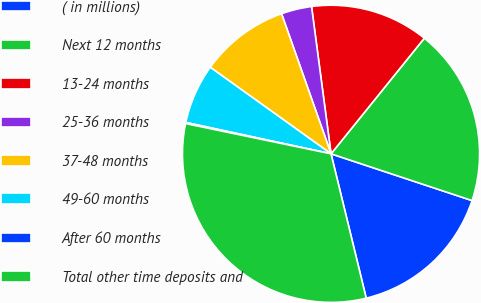Convert chart to OTSL. <chart><loc_0><loc_0><loc_500><loc_500><pie_chart><fcel>( in millions)<fcel>Next 12 months<fcel>13-24 months<fcel>25-36 months<fcel>37-48 months<fcel>49-60 months<fcel>After 60 months<fcel>Total other time deposits and<nl><fcel>16.1%<fcel>19.29%<fcel>12.9%<fcel>3.31%<fcel>9.7%<fcel>6.51%<fcel>0.12%<fcel>32.07%<nl></chart> 